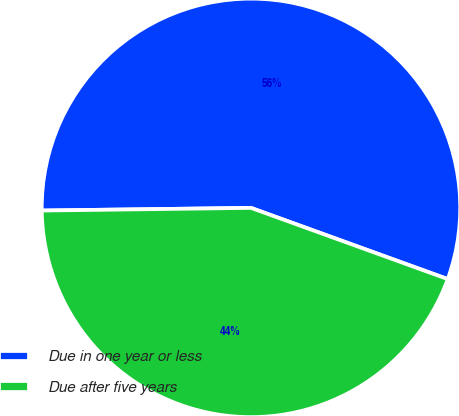<chart> <loc_0><loc_0><loc_500><loc_500><pie_chart><fcel>Due in one year or less<fcel>Due after five years<nl><fcel>55.73%<fcel>44.27%<nl></chart> 